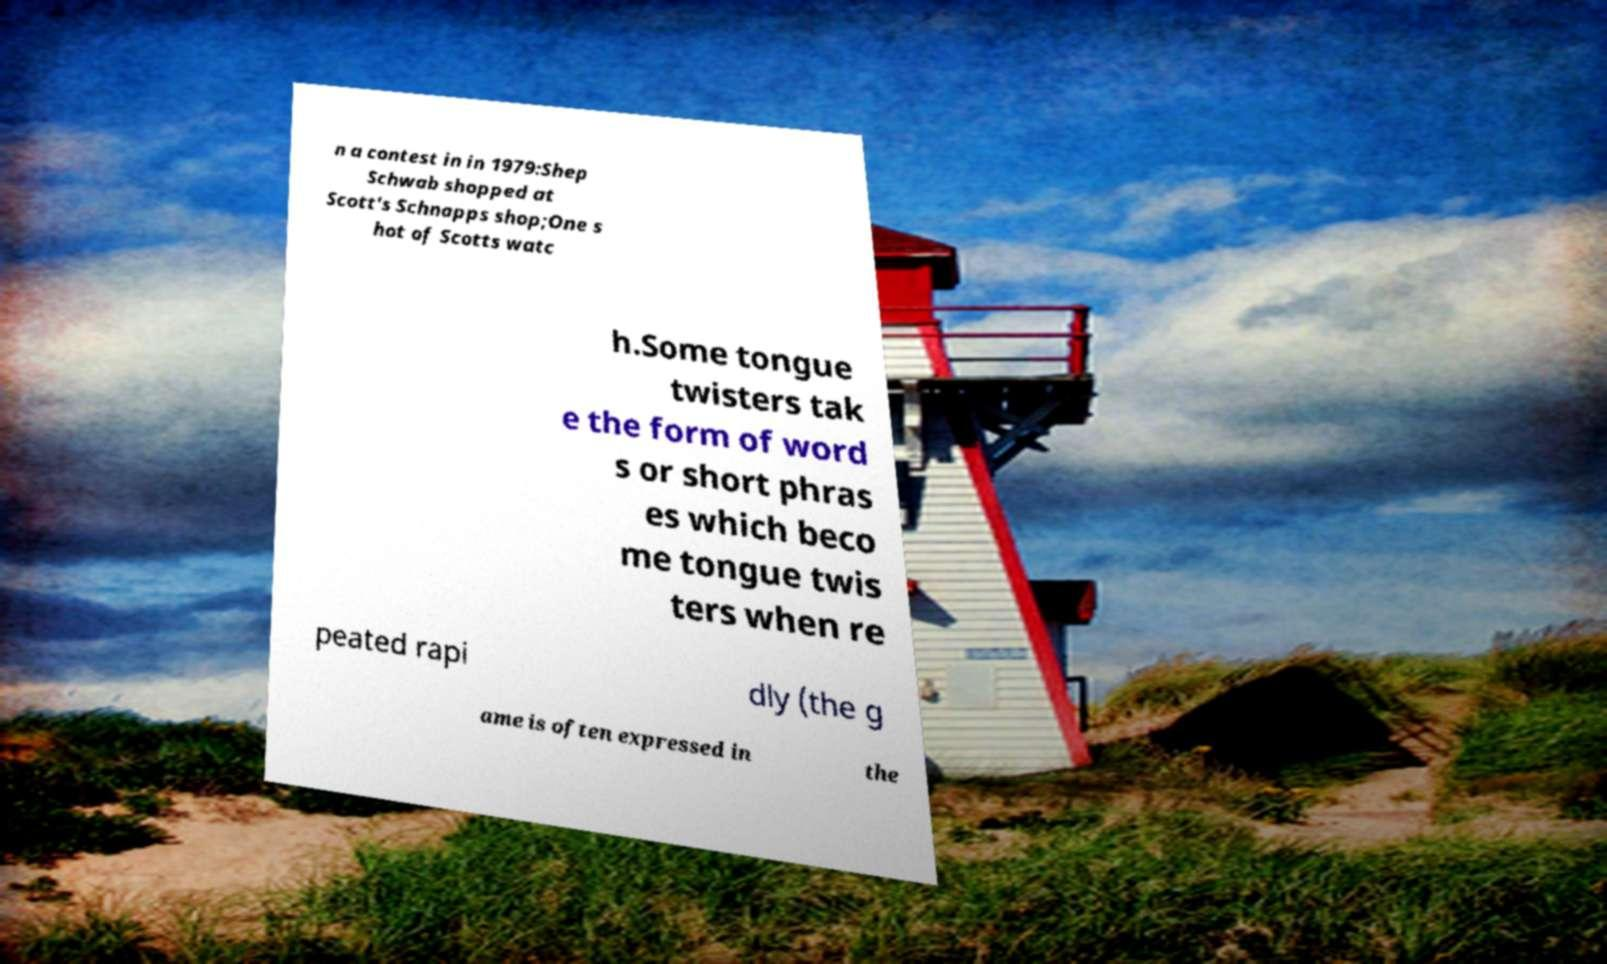Can you accurately transcribe the text from the provided image for me? n a contest in in 1979:Shep Schwab shopped at Scott's Schnapps shop;One s hot of Scotts watc h.Some tongue twisters tak e the form of word s or short phras es which beco me tongue twis ters when re peated rapi dly (the g ame is often expressed in the 